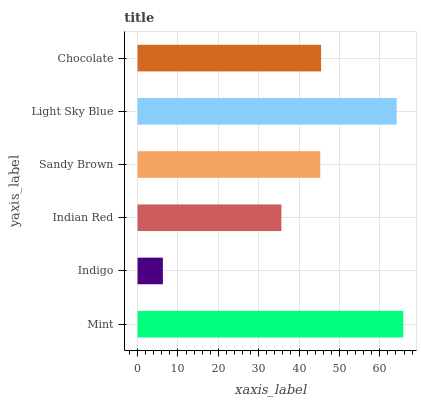Is Indigo the minimum?
Answer yes or no. Yes. Is Mint the maximum?
Answer yes or no. Yes. Is Indian Red the minimum?
Answer yes or no. No. Is Indian Red the maximum?
Answer yes or no. No. Is Indian Red greater than Indigo?
Answer yes or no. Yes. Is Indigo less than Indian Red?
Answer yes or no. Yes. Is Indigo greater than Indian Red?
Answer yes or no. No. Is Indian Red less than Indigo?
Answer yes or no. No. Is Chocolate the high median?
Answer yes or no. Yes. Is Sandy Brown the low median?
Answer yes or no. Yes. Is Indian Red the high median?
Answer yes or no. No. Is Indigo the low median?
Answer yes or no. No. 